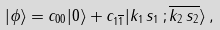<formula> <loc_0><loc_0><loc_500><loc_500>| \phi \rangle = c _ { 0 0 } | 0 \rangle + c _ { 1 \overline { 1 } } | k _ { 1 } \, s _ { 1 } \, ; \overline { k _ { 2 } \, s _ { 2 } } \rangle \, ,</formula> 